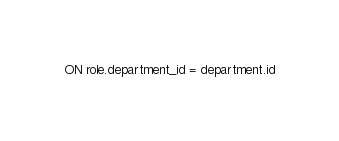Convert code to text. <code><loc_0><loc_0><loc_500><loc_500><_SQL_>ON role.department_id = department.id






</code> 